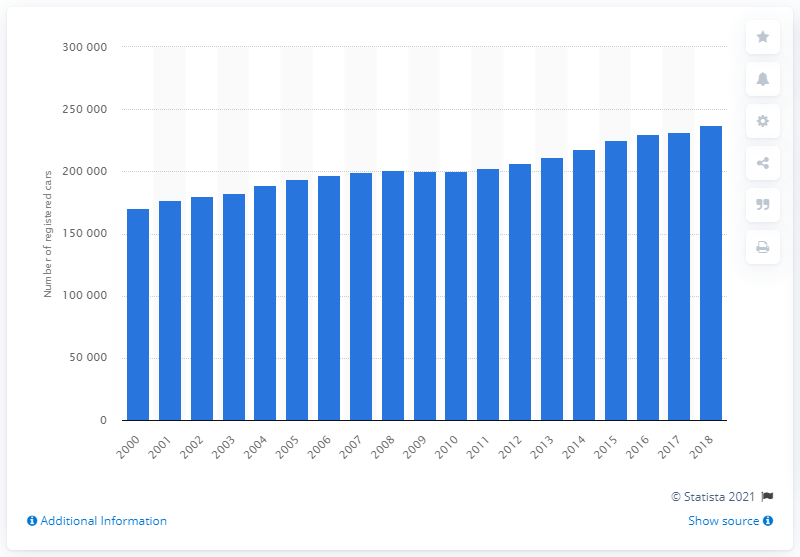What trends can we observe from the histogram about car registrations in Great Britain from 2000 to 2018? The histogram suggests a steady increase in the number of car registrations in Great Britain from 2000 to 2008, followed by fluctuations and a general leveling out or slight decrease towards 2018. This could indicate market saturation, economic impacts, or changes in consumer behavior during that period.  Could you infer any potential reasons for the fluctuation in car registration numbers shown? Fluctuations in car registration numbers could be influenced by various factors, including economic downturns such as the financial crisis around 2008, changes in vehicle taxation, advances in technology leading to ridesharing or the increase in electric vehicle options, as well as broader environmental concerns affecting consumer choices. 